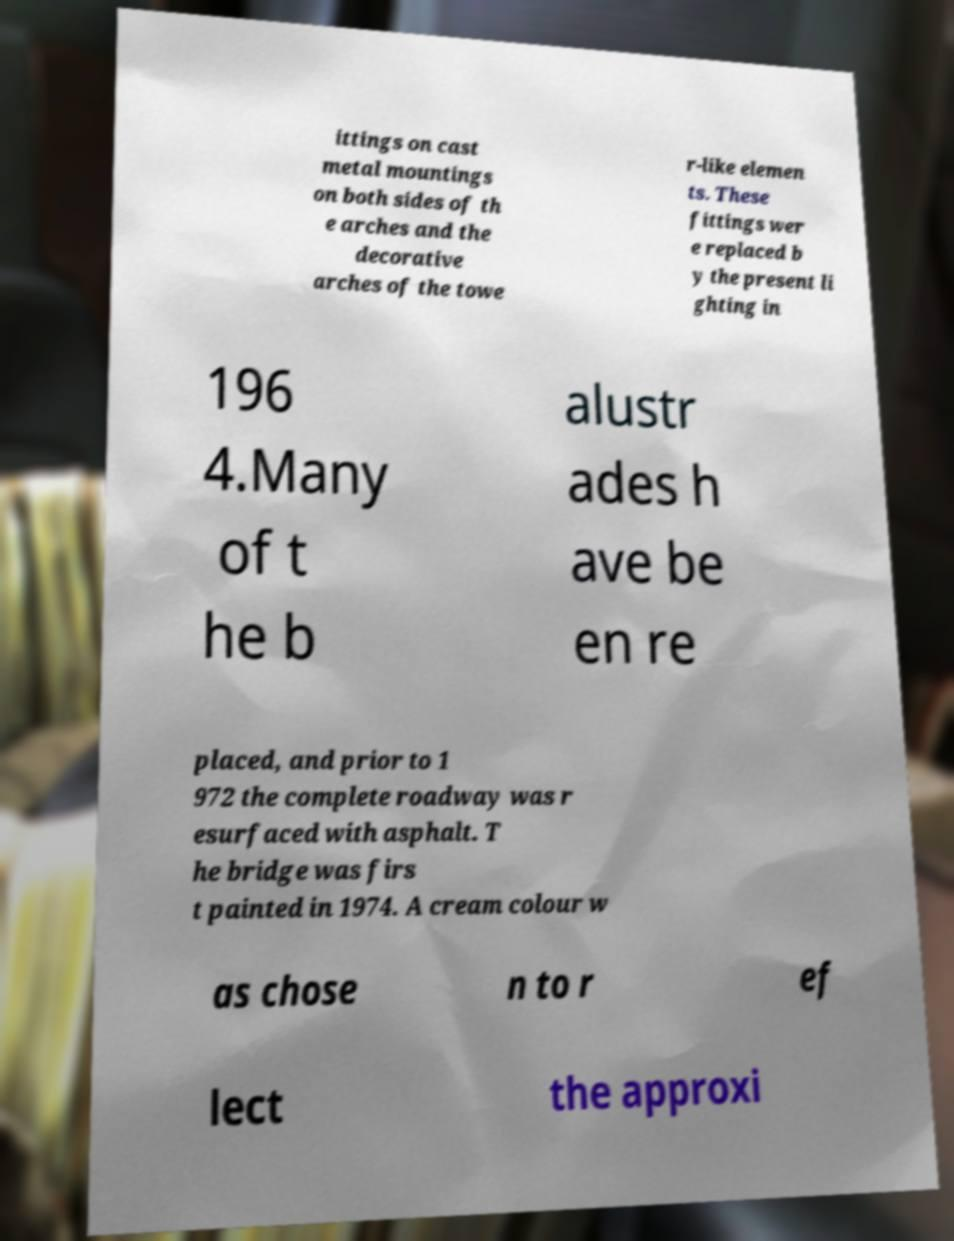Please read and relay the text visible in this image. What does it say? ittings on cast metal mountings on both sides of th e arches and the decorative arches of the towe r-like elemen ts. These fittings wer e replaced b y the present li ghting in 196 4.Many of t he b alustr ades h ave be en re placed, and prior to 1 972 the complete roadway was r esurfaced with asphalt. T he bridge was firs t painted in 1974. A cream colour w as chose n to r ef lect the approxi 